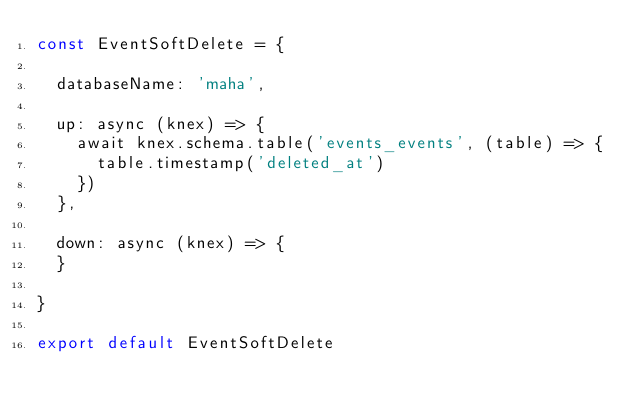Convert code to text. <code><loc_0><loc_0><loc_500><loc_500><_JavaScript_>const EventSoftDelete = {

  databaseName: 'maha',

  up: async (knex) => {
    await knex.schema.table('events_events', (table) => {
      table.timestamp('deleted_at')
    })
  },

  down: async (knex) => {
  }

}

export default EventSoftDelete
</code> 